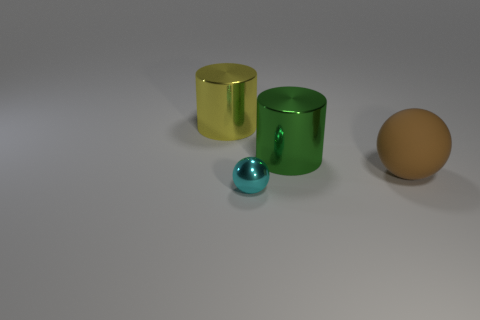What number of big things are either green cylinders or cyan things?
Your answer should be very brief. 1. There is a brown matte thing that is the same size as the yellow thing; what is its shape?
Give a very brief answer. Sphere. Is there any other thing that is the same size as the shiny sphere?
Your answer should be very brief. No. What is the material of the ball in front of the brown rubber ball that is on the right side of the big yellow cylinder?
Offer a terse response. Metal. Does the matte ball have the same size as the cyan ball?
Provide a short and direct response. No. How many objects are either big metallic cylinders that are in front of the large yellow cylinder or metal objects?
Offer a terse response. 3. The brown rubber thing that is behind the sphere that is on the left side of the big brown matte object is what shape?
Provide a succinct answer. Sphere. Is the size of the cyan metallic ball the same as the rubber object that is in front of the big green metal object?
Offer a very short reply. No. What is the material of the cylinder that is to the right of the big yellow object?
Make the answer very short. Metal. What number of things are both to the left of the green object and behind the small object?
Ensure brevity in your answer.  1. 